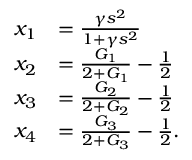Convert formula to latex. <formula><loc_0><loc_0><loc_500><loc_500>\begin{array} { r l } { x _ { 1 } } & { = \frac { \gamma s ^ { 2 } } { 1 + \gamma s ^ { 2 } } } \\ { x _ { 2 } } & { = \frac { G _ { 1 } } { 2 + G _ { 1 } } - \frac { 1 } { 2 } } \\ { x _ { 3 } } & { = \frac { G _ { 2 } } { 2 + G _ { 2 } } - \frac { 1 } { 2 } } \\ { x _ { 4 } } & { = \frac { G _ { 3 } } { 2 + G _ { 3 } } - \frac { 1 } { 2 } . } \end{array}</formula> 